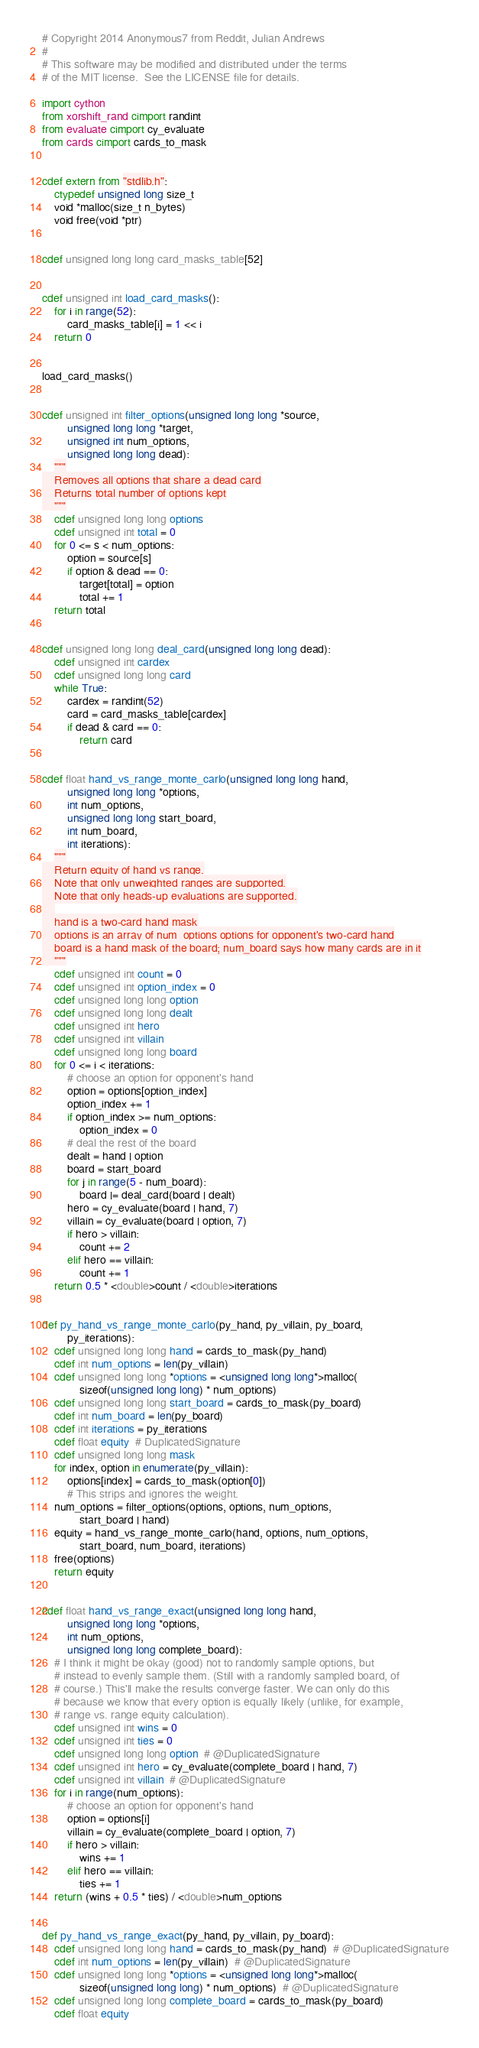<code> <loc_0><loc_0><loc_500><loc_500><_Cython_># Copyright 2014 Anonymous7 from Reddit, Julian Andrews
#
# This software may be modified and distributed under the terms
# of the MIT license.  See the LICENSE file for details.

import cython
from xorshift_rand cimport randint
from evaluate cimport cy_evaluate
from cards cimport cards_to_mask


cdef extern from "stdlib.h":
    ctypedef unsigned long size_t
    void *malloc(size_t n_bytes)
    void free(void *ptr)


cdef unsigned long long card_masks_table[52]


cdef unsigned int load_card_masks():
    for i in range(52):
        card_masks_table[i] = 1 << i
    return 0


load_card_masks()


cdef unsigned int filter_options(unsigned long long *source, 
        unsigned long long *target, 
        unsigned int num_options, 
        unsigned long long dead):
    """
    Removes all options that share a dead card
    Returns total number of options kept
    """
    cdef unsigned long long options
    cdef unsigned int total = 0
    for 0 <= s < num_options:
        option = source[s]
        if option & dead == 0:
            target[total] = option
            total += 1
    return total


cdef unsigned long long deal_card(unsigned long long dead):
    cdef unsigned int cardex
    cdef unsigned long long card
    while True:
        cardex = randint(52)
        card = card_masks_table[cardex]
        if dead & card == 0:
            return card


cdef float hand_vs_range_monte_carlo(unsigned long long hand, 
        unsigned long long *options, 
        int num_options, 
        unsigned long long start_board, 
        int num_board, 
        int iterations):
    """
    Return equity of hand vs range.
    Note that only unweighted ranges are supported.
    Note that only heads-up evaluations are supported.
    
    hand is a two-card hand mask
    options is an array of num_options options for opponent's two-card hand
    board is a hand mask of the board; num_board says how many cards are in it
    """
    cdef unsigned int count = 0
    cdef unsigned int option_index = 0
    cdef unsigned long long option
    cdef unsigned long long dealt
    cdef unsigned int hero
    cdef unsigned int villain
    cdef unsigned long long board
    for 0 <= i < iterations:
        # choose an option for opponent's hand
        option = options[option_index]
        option_index += 1
        if option_index >= num_options:
            option_index = 0
        # deal the rest of the board
        dealt = hand | option
        board = start_board
        for j in range(5 - num_board):
            board |= deal_card(board | dealt)
        hero = cy_evaluate(board | hand, 7)
        villain = cy_evaluate(board | option, 7)
        if hero > villain:
            count += 2
        elif hero == villain:
            count += 1
    return 0.5 * <double>count / <double>iterations


def py_hand_vs_range_monte_carlo(py_hand, py_villain, py_board, 
        py_iterations):
    cdef unsigned long long hand = cards_to_mask(py_hand)
    cdef int num_options = len(py_villain)
    cdef unsigned long long *options = <unsigned long long*>malloc(
            sizeof(unsigned long long) * num_options)
    cdef unsigned long long start_board = cards_to_mask(py_board)
    cdef int num_board = len(py_board)
    cdef int iterations = py_iterations
    cdef float equity  # DuplicatedSignature
    cdef unsigned long long mask
    for index, option in enumerate(py_villain):
        options[index] = cards_to_mask(option[0])
        # This strips and ignores the weight.
    num_options = filter_options(options, options, num_options, 
            start_board | hand)
    equity = hand_vs_range_monte_carlo(hand, options, num_options, 
            start_board, num_board, iterations)
    free(options)
    return equity


cdef float hand_vs_range_exact(unsigned long long hand, 
        unsigned long long *options, 
        int num_options, 
        unsigned long long complete_board):
    # I think it might be okay (good) not to randomly sample options, but
    # instead to evenly sample them. (Still with a randomly sampled board, of
    # course.) This'll make the results converge faster. We can only do this
    # because we know that every option is equally likely (unlike, for example,
    # range vs. range equity calculation).
    cdef unsigned int wins = 0
    cdef unsigned int ties = 0
    cdef unsigned long long option  # @DuplicatedSignature
    cdef unsigned int hero = cy_evaluate(complete_board | hand, 7)
    cdef unsigned int villain  # @DuplicatedSignature
    for i in range(num_options):
        # choose an option for opponent's hand
        option = options[i]
        villain = cy_evaluate(complete_board | option, 7)
        if hero > villain:
            wins += 1
        elif hero == villain:
            ties += 1
    return (wins + 0.5 * ties) / <double>num_options


def py_hand_vs_range_exact(py_hand, py_villain, py_board):
    cdef unsigned long long hand = cards_to_mask(py_hand)  # @DuplicatedSignature
    cdef int num_options = len(py_villain)  # @DuplicatedSignature
    cdef unsigned long long *options = <unsigned long long*>malloc(
            sizeof(unsigned long long) * num_options)  # @DuplicatedSignature
    cdef unsigned long long complete_board = cards_to_mask(py_board)
    cdef float equity</code> 